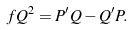Convert formula to latex. <formula><loc_0><loc_0><loc_500><loc_500>f Q ^ { 2 } = P ^ { \prime } Q - Q ^ { \prime } P .</formula> 